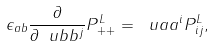<formula> <loc_0><loc_0><loc_500><loc_500>\epsilon _ { a b } \frac { \partial } { \partial \ u b b ^ { j } } P ^ { L } _ { + + } = \ u a a ^ { i } P ^ { L } _ { i j } ,</formula> 